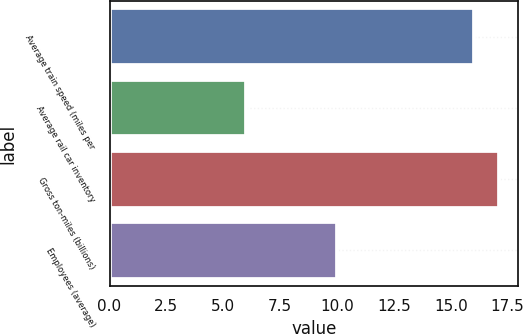<chart> <loc_0><loc_0><loc_500><loc_500><bar_chart><fcel>Average train speed (miles per<fcel>Average rail car inventory<fcel>Gross ton-miles (billions)<fcel>Employees (average)<nl><fcel>16<fcel>6<fcel>17.1<fcel>10<nl></chart> 